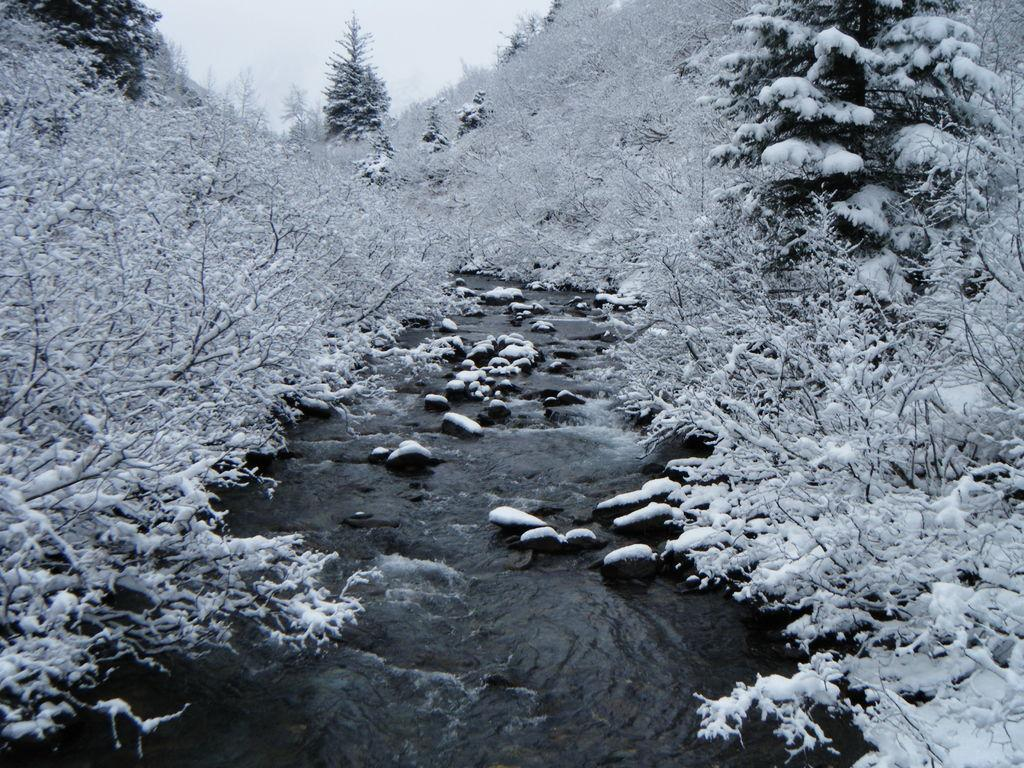What type of vegetation can be seen in the image? There are trees in the image. What natural element is visible besides the trees? There is water visible in the image. How would you describe the sky in the image? The sky appears to be cloudy. What type of material is present in the image? There are stones present in the image. What time of day is it in the image, and what key is used to unlock the door? The time of day cannot be determined from the image, and there is no door or key present in the image. 